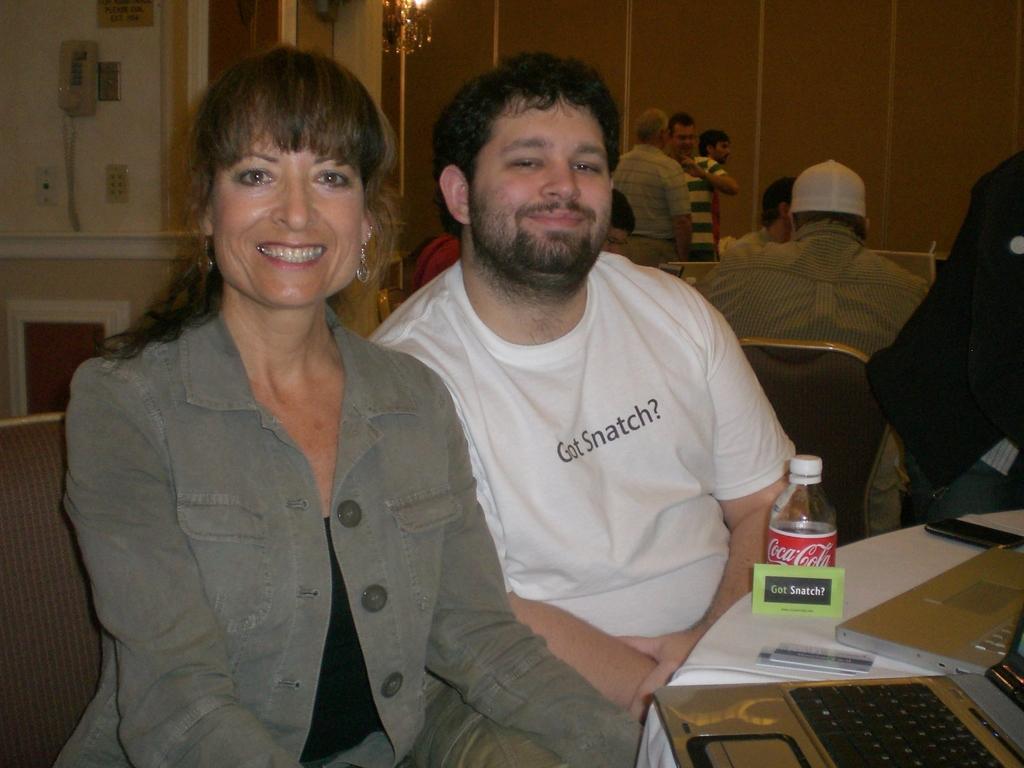In one or two sentences, can you explain what this image depicts? There is a group of people. Some people are sitting on a chair and some people are standing. There is a table. There is a bottle,laptop,mobile on a table. 